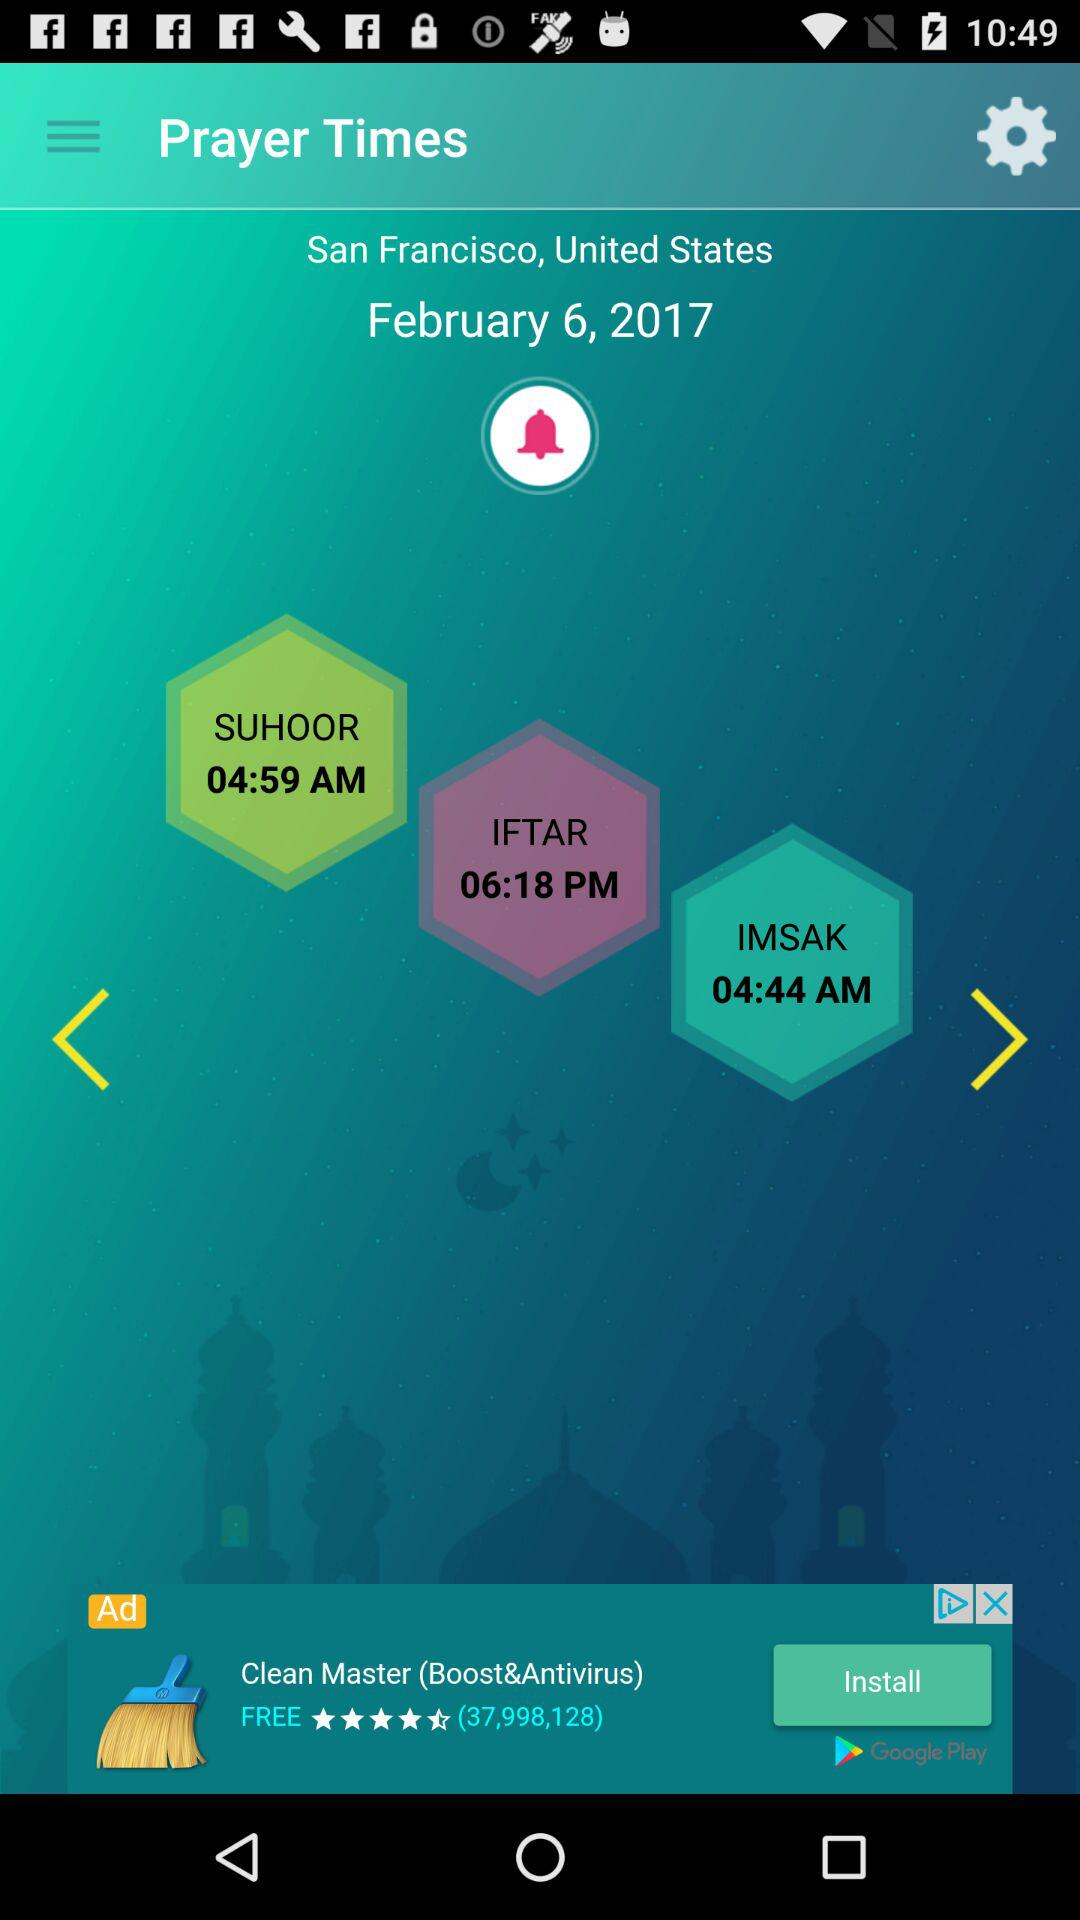Which date is mentioned for prayer? The mentioned date is February 6, 2017. 